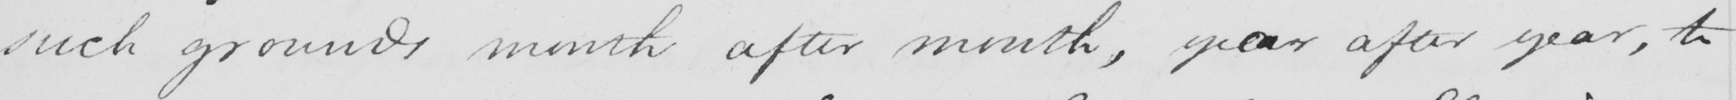What does this handwritten line say? such grounds month after month , yeeaar after year , to 